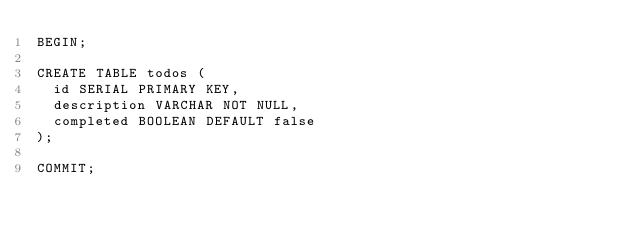Convert code to text. <code><loc_0><loc_0><loc_500><loc_500><_SQL_>BEGIN;

CREATE TABLE todos (
  id SERIAL PRIMARY KEY,
  description VARCHAR NOT NULL,
  completed BOOLEAN DEFAULT false
);

COMMIT;</code> 